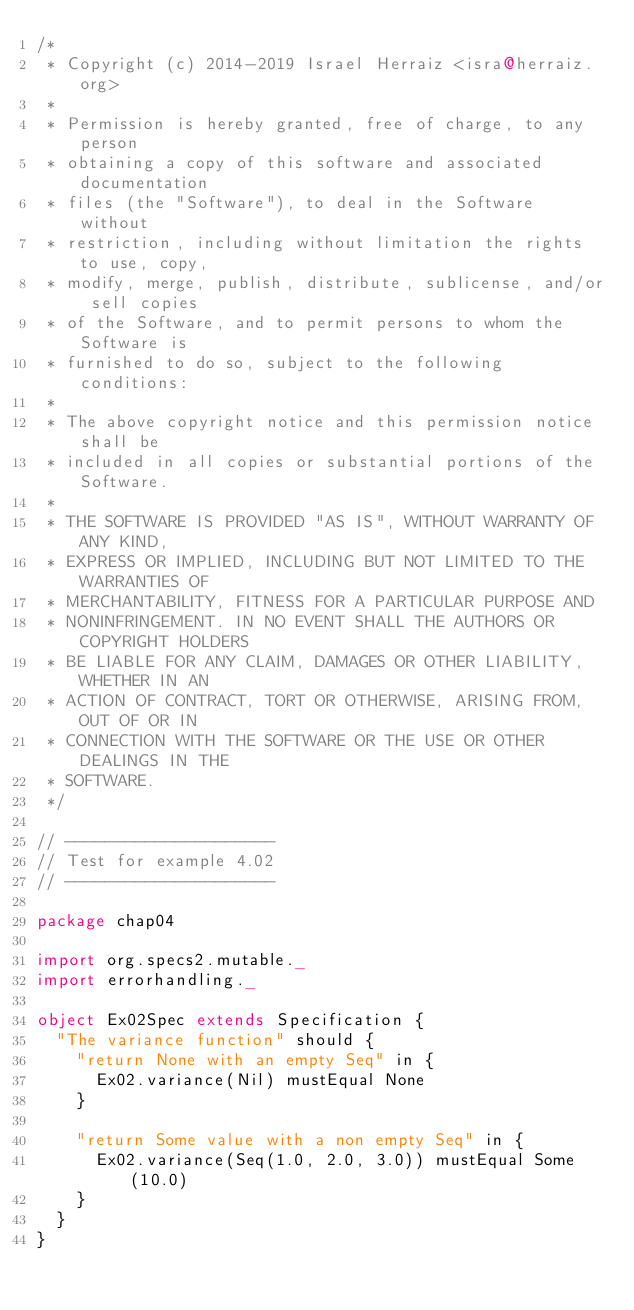<code> <loc_0><loc_0><loc_500><loc_500><_Scala_>/*
 * Copyright (c) 2014-2019 Israel Herraiz <isra@herraiz.org>
 *
 * Permission is hereby granted, free of charge, to any person
 * obtaining a copy of this software and associated documentation
 * files (the "Software"), to deal in the Software without
 * restriction, including without limitation the rights to use, copy,
 * modify, merge, publish, distribute, sublicense, and/or sell copies
 * of the Software, and to permit persons to whom the Software is
 * furnished to do so, subject to the following conditions:
 *
 * The above copyright notice and this permission notice shall be
 * included in all copies or substantial portions of the Software.
 *
 * THE SOFTWARE IS PROVIDED "AS IS", WITHOUT WARRANTY OF ANY KIND,
 * EXPRESS OR IMPLIED, INCLUDING BUT NOT LIMITED TO THE WARRANTIES OF
 * MERCHANTABILITY, FITNESS FOR A PARTICULAR PURPOSE AND
 * NONINFRINGEMENT. IN NO EVENT SHALL THE AUTHORS OR COPYRIGHT HOLDERS
 * BE LIABLE FOR ANY CLAIM, DAMAGES OR OTHER LIABILITY, WHETHER IN AN
 * ACTION OF CONTRACT, TORT OR OTHERWISE, ARISING FROM, OUT OF OR IN
 * CONNECTION WITH THE SOFTWARE OR THE USE OR OTHER DEALINGS IN THE
 * SOFTWARE.
 */  

// ---------------------
// Test for example 4.02
// ---------------------

package chap04

import org.specs2.mutable._
import errorhandling._

object Ex02Spec extends Specification {
  "The variance function" should {
    "return None with an empty Seq" in {
      Ex02.variance(Nil) mustEqual None
    }

    "return Some value with a non empty Seq" in {
      Ex02.variance(Seq(1.0, 2.0, 3.0)) mustEqual Some(10.0)
    }
  }  
}
</code> 